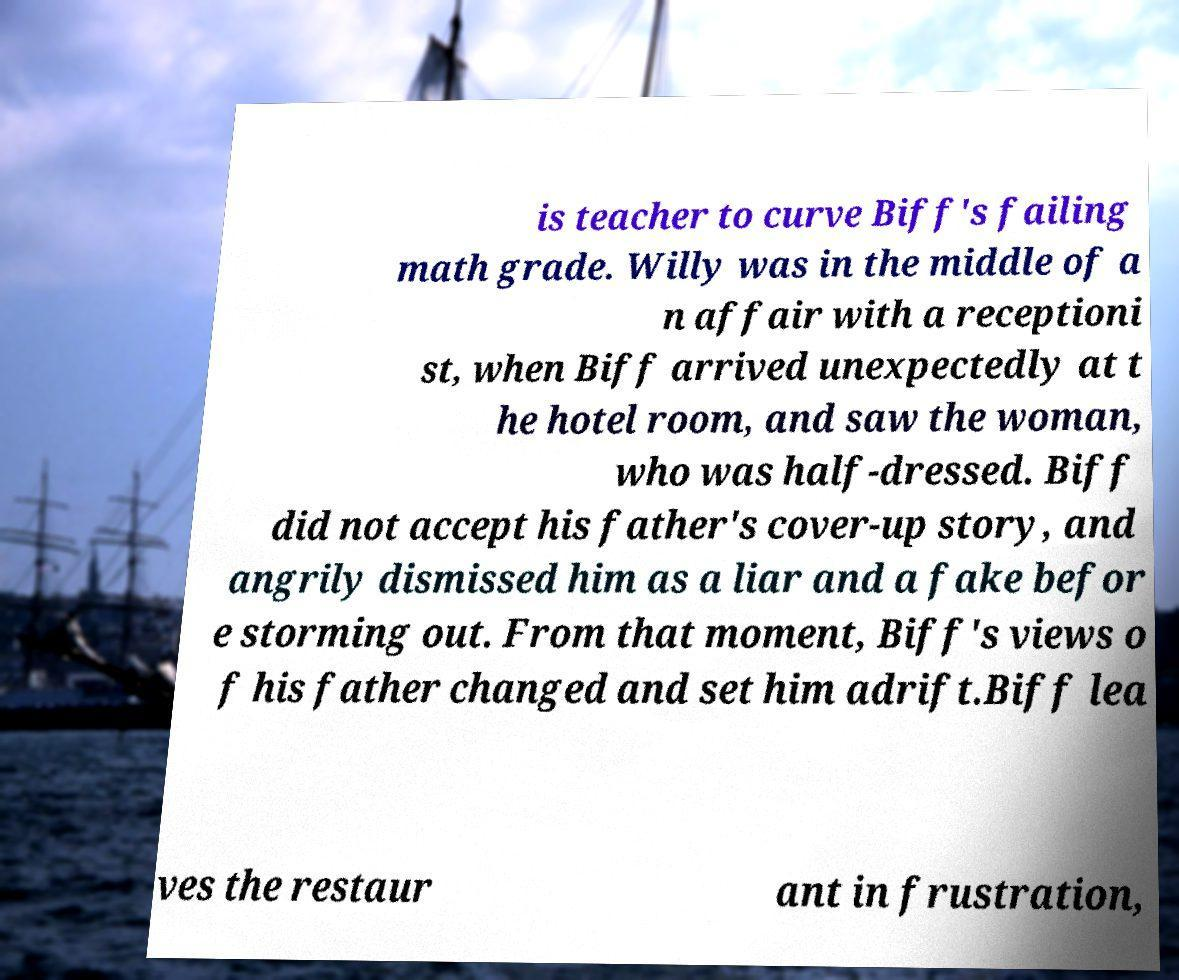Can you read and provide the text displayed in the image?This photo seems to have some interesting text. Can you extract and type it out for me? is teacher to curve Biff's failing math grade. Willy was in the middle of a n affair with a receptioni st, when Biff arrived unexpectedly at t he hotel room, and saw the woman, who was half-dressed. Biff did not accept his father's cover-up story, and angrily dismissed him as a liar and a fake befor e storming out. From that moment, Biff's views o f his father changed and set him adrift.Biff lea ves the restaur ant in frustration, 